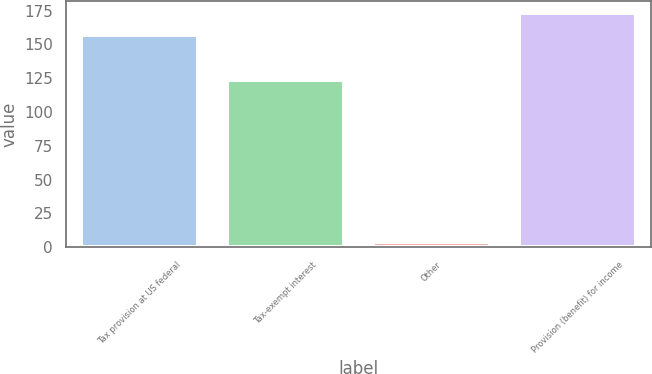<chart> <loc_0><loc_0><loc_500><loc_500><bar_chart><fcel>Tax provision at US federal<fcel>Tax-exempt interest<fcel>Other<fcel>Provision (benefit) for income<nl><fcel>157<fcel>124<fcel>4<fcel>173.2<nl></chart> 